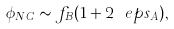Convert formula to latex. <formula><loc_0><loc_0><loc_500><loc_500>\phi _ { N C } \sim f _ { B } ( 1 + 2 \ e p s _ { A } ) ,</formula> 